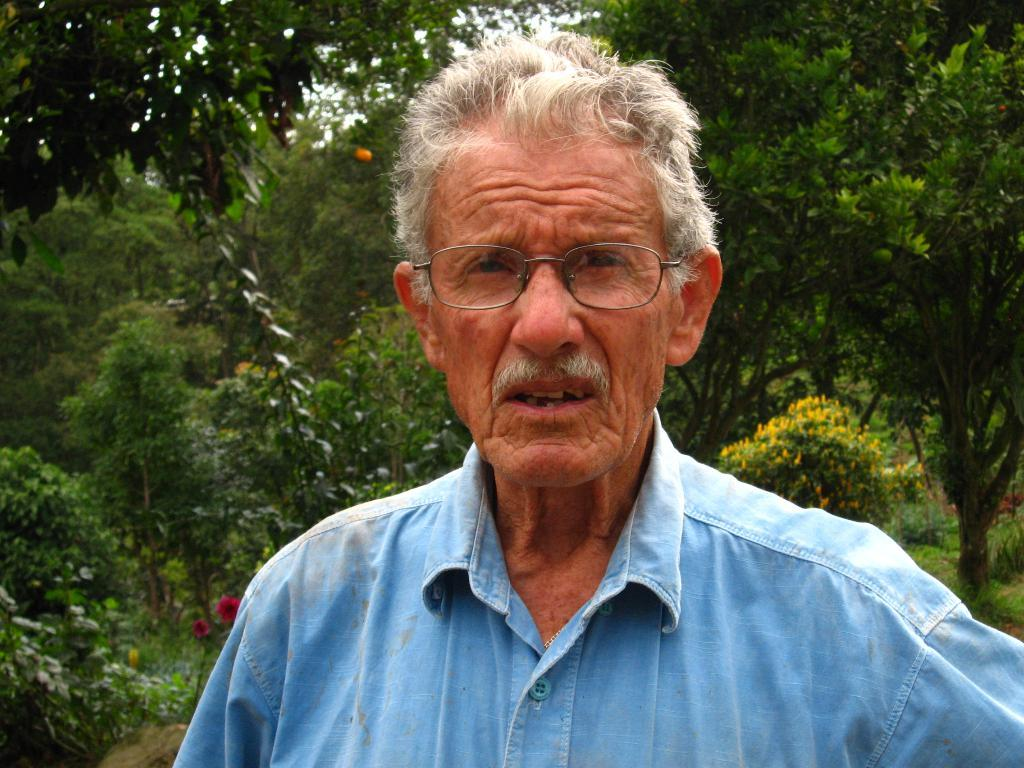Who or what is present in the image? There is a person in the image. What can be seen in the background of the image? There are flowers and plants in the background of the image. What type of spoon can be seen in the person's hand in the image? There is no spoon present in the image; only a person and background elements are visible. 